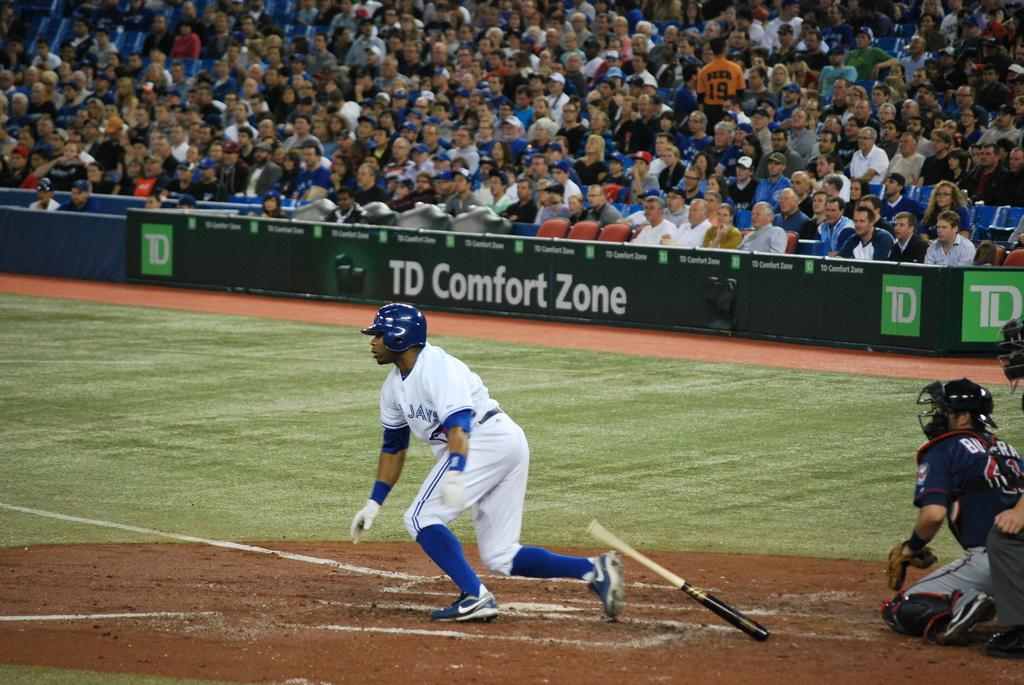What animal can be seen in the image? There is a bat in the image. What is the location of the people in the image? The persons are on the sports ground. What type of signage is present in the image? Advertising boards are present in the image. Who else is present in the image besides the persons on the sports ground? Spectators are visible in the image. What is the length of the boundary line in the image? There is no boundary line present in the image, so it cannot be measured. 